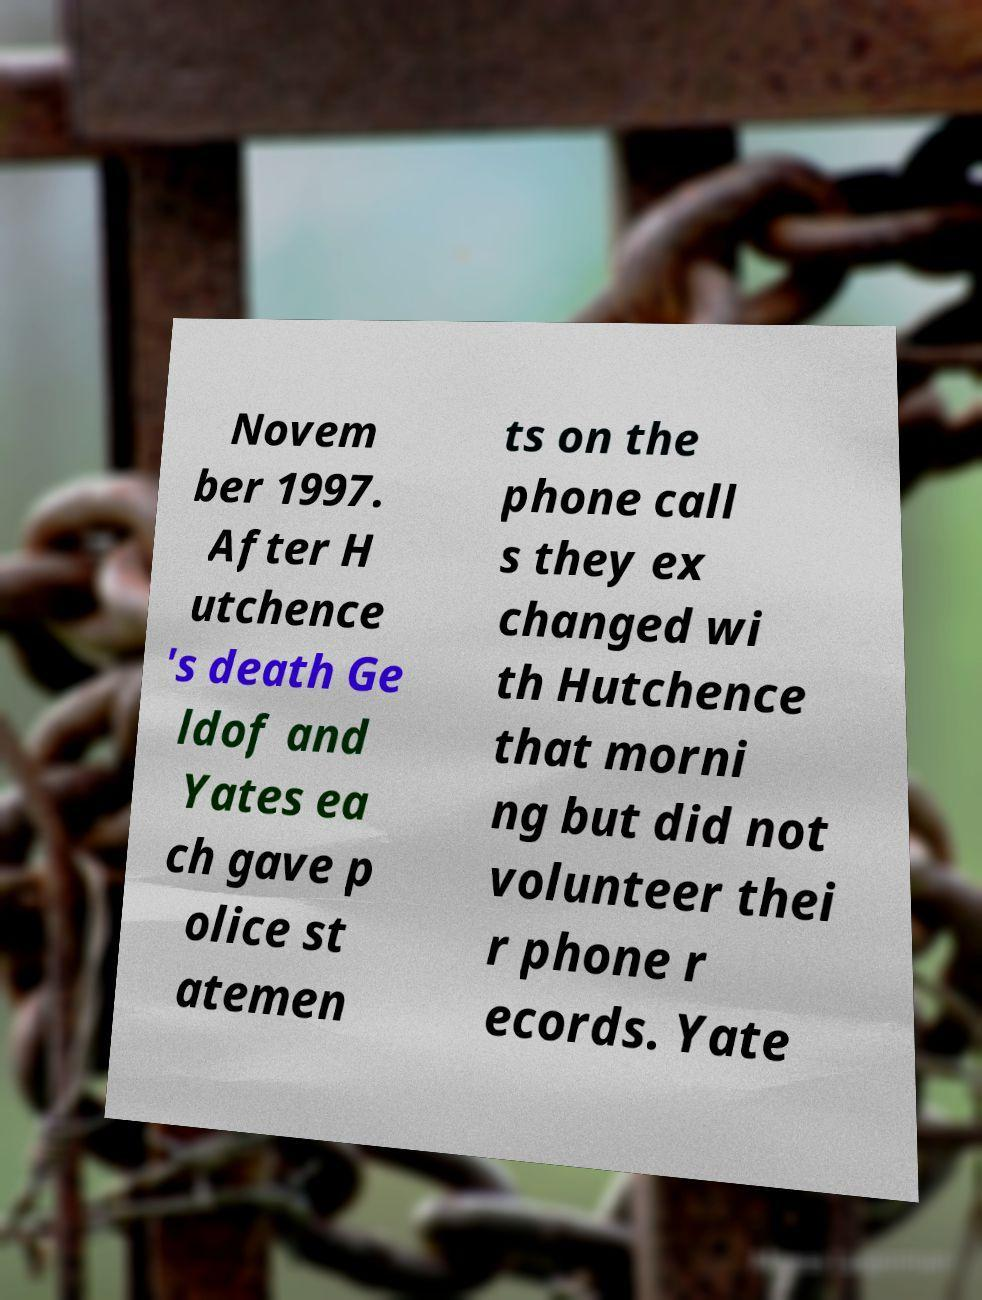Could you assist in decoding the text presented in this image and type it out clearly? Novem ber 1997. After H utchence 's death Ge ldof and Yates ea ch gave p olice st atemen ts on the phone call s they ex changed wi th Hutchence that morni ng but did not volunteer thei r phone r ecords. Yate 